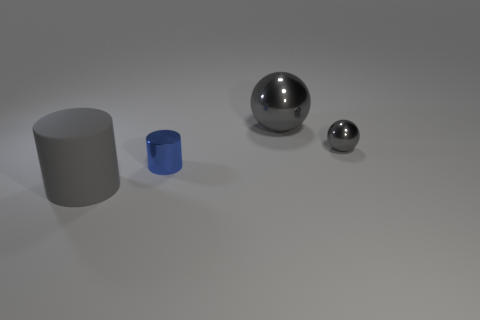How would you describe the illumination in this scene? The scene is softly lit with diffuse light, which creates gentle shadows and highlights the surfaces of the objects without sharp contrasts. This gives a calm and balanced ambiance to the image. What does that kind of lighting suggest about the setting? This kind of lighting is typical of a controlled environment, such as a studio setting, where light is intentionally diffused to avoid harsh shadows and achieve a neutral backdrop for the objects. 